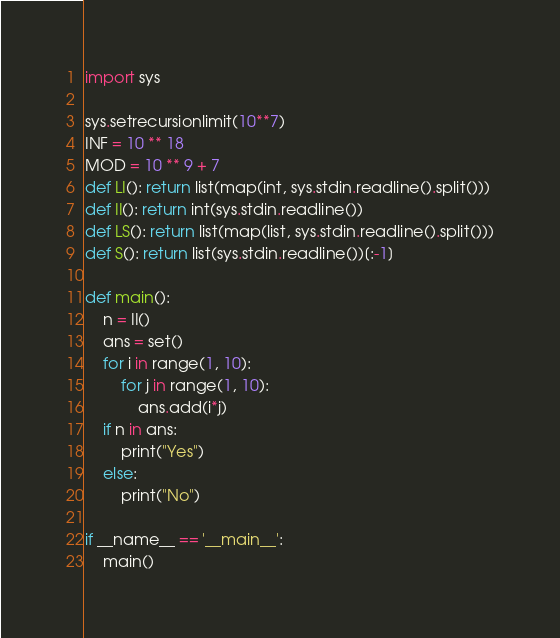Convert code to text. <code><loc_0><loc_0><loc_500><loc_500><_Python_>import sys

sys.setrecursionlimit(10**7)
INF = 10 ** 18
MOD = 10 ** 9 + 7
def LI(): return list(map(int, sys.stdin.readline().split()))
def II(): return int(sys.stdin.readline())
def LS(): return list(map(list, sys.stdin.readline().split()))
def S(): return list(sys.stdin.readline())[:-1]

def main():
    n = II()
    ans = set()
    for i in range(1, 10):
        for j in range(1, 10):
            ans.add(i*j)
    if n in ans:
        print("Yes")
    else:
        print("No")

if __name__ == '__main__':
    main()</code> 